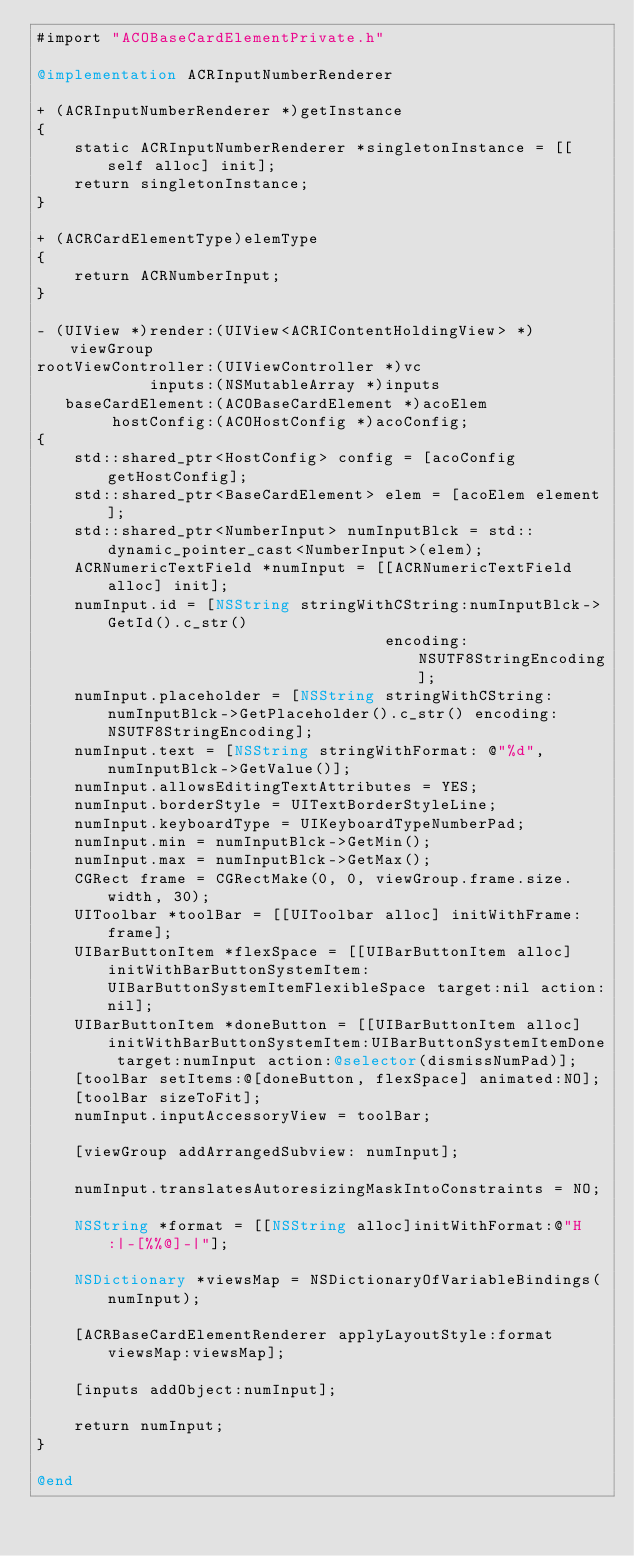Convert code to text. <code><loc_0><loc_0><loc_500><loc_500><_ObjectiveC_>#import "ACOBaseCardElementPrivate.h"

@implementation ACRInputNumberRenderer

+ (ACRInputNumberRenderer *)getInstance
{
    static ACRInputNumberRenderer *singletonInstance = [[self alloc] init];
    return singletonInstance;
}

+ (ACRCardElementType)elemType
{
    return ACRNumberInput;
}

- (UIView *)render:(UIView<ACRIContentHoldingView> *)viewGroup
rootViewController:(UIViewController *)vc
            inputs:(NSMutableArray *)inputs
   baseCardElement:(ACOBaseCardElement *)acoElem
        hostConfig:(ACOHostConfig *)acoConfig;
{
    std::shared_ptr<HostConfig> config = [acoConfig getHostConfig];
    std::shared_ptr<BaseCardElement> elem = [acoElem element];
    std::shared_ptr<NumberInput> numInputBlck = std::dynamic_pointer_cast<NumberInput>(elem);
    ACRNumericTextField *numInput = [[ACRNumericTextField alloc] init];
    numInput.id = [NSString stringWithCString:numInputBlck->GetId().c_str()
                                     encoding:NSUTF8StringEncoding];
    numInput.placeholder = [NSString stringWithCString:numInputBlck->GetPlaceholder().c_str() encoding:NSUTF8StringEncoding];
    numInput.text = [NSString stringWithFormat: @"%d", numInputBlck->GetValue()];
    numInput.allowsEditingTextAttributes = YES;
    numInput.borderStyle = UITextBorderStyleLine;
    numInput.keyboardType = UIKeyboardTypeNumberPad;
    numInput.min = numInputBlck->GetMin();
    numInput.max = numInputBlck->GetMax();
    CGRect frame = CGRectMake(0, 0, viewGroup.frame.size.width, 30);
    UIToolbar *toolBar = [[UIToolbar alloc] initWithFrame:frame];
    UIBarButtonItem *flexSpace = [[UIBarButtonItem alloc] initWithBarButtonSystemItem:UIBarButtonSystemItemFlexibleSpace target:nil action:nil];
    UIBarButtonItem *doneButton = [[UIBarButtonItem alloc] initWithBarButtonSystemItem:UIBarButtonSystemItemDone target:numInput action:@selector(dismissNumPad)];
    [toolBar setItems:@[doneButton, flexSpace] animated:NO];
    [toolBar sizeToFit];
    numInput.inputAccessoryView = toolBar;

    [viewGroup addArrangedSubview: numInput];

    numInput.translatesAutoresizingMaskIntoConstraints = NO;

    NSString *format = [[NSString alloc]initWithFormat:@"H:|-[%%@]-|"];

    NSDictionary *viewsMap = NSDictionaryOfVariableBindings(numInput);

    [ACRBaseCardElementRenderer applyLayoutStyle:format viewsMap:viewsMap];

    [inputs addObject:numInput];

    return numInput;
}

@end
</code> 